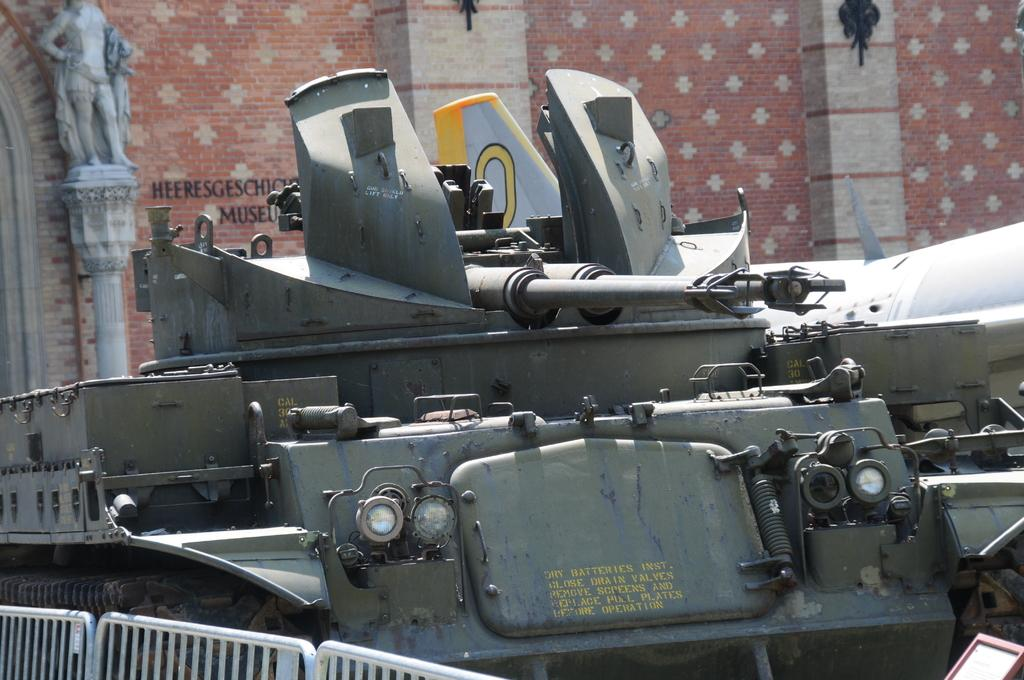What is the main subject in the image? There is a vehicle in the image. What can be seen in the background of the image? There is a wall in the background of the image. Can you describe the appearance of the wall? The wall has a cream and light brown color. color. How many rabbits are sitting on the vehicle in the image? There are no rabbits present in the image; it only features a vehicle and a wall in the background. 